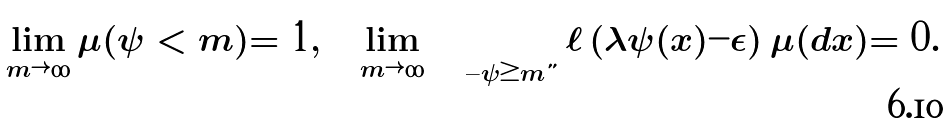<formula> <loc_0><loc_0><loc_500><loc_500>\lim _ { m \rightarrow \infty } \mu ( \psi < m ) = 1 , \quad \lim _ { m \rightarrow \infty } \int _ { \{ \psi \geq m \} } \ell \left ( \lambda \psi ( x ) - \epsilon \right ) \mu ( d x ) = 0 .</formula> 